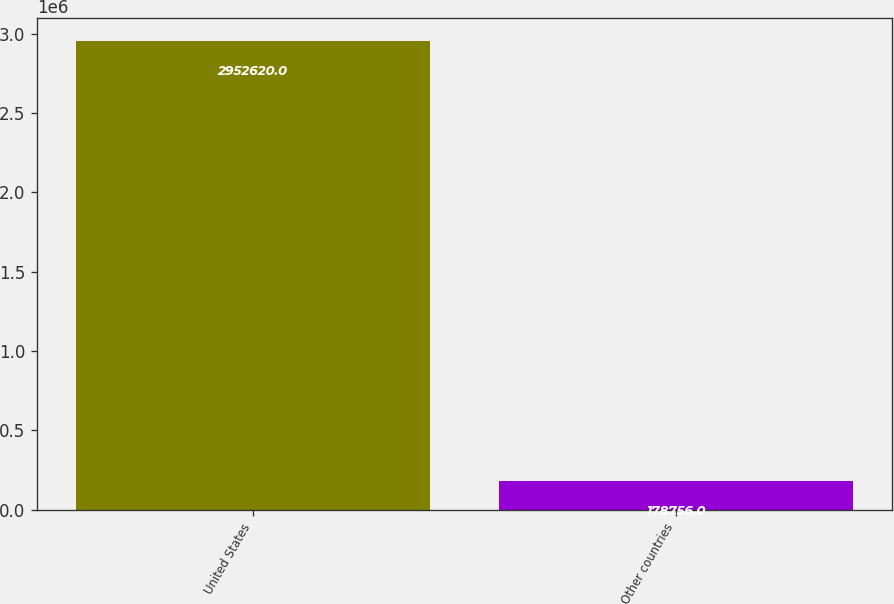Convert chart to OTSL. <chart><loc_0><loc_0><loc_500><loc_500><bar_chart><fcel>United States<fcel>Other countries<nl><fcel>2.95262e+06<fcel>178756<nl></chart> 